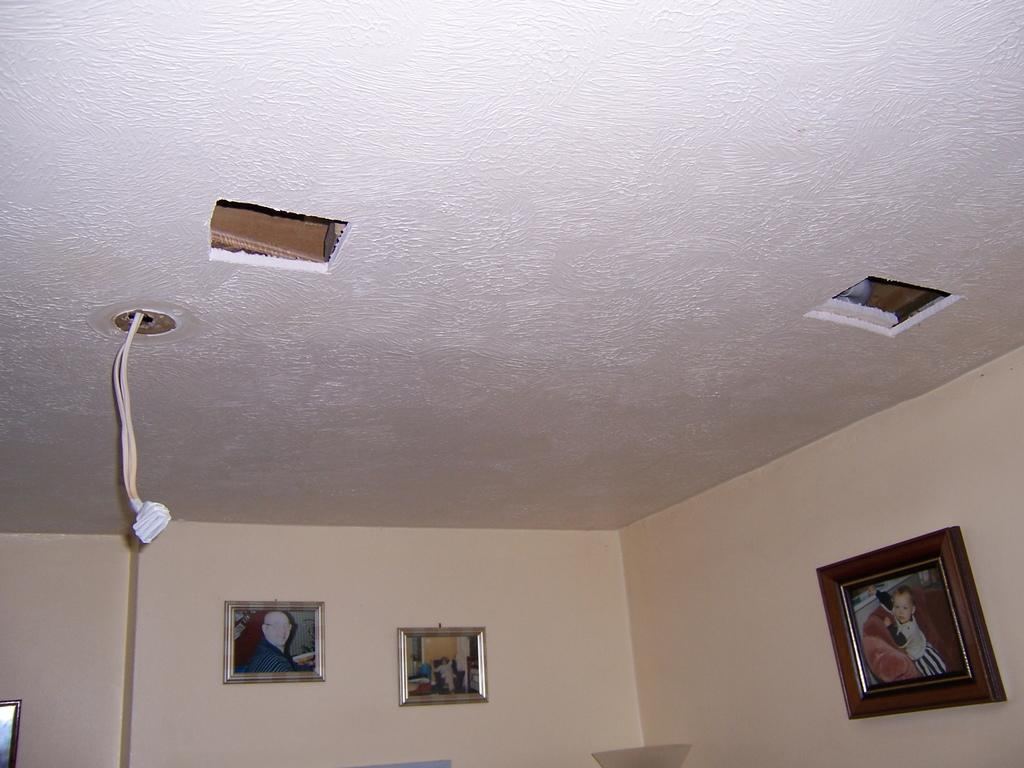Where was the image taken? The image was taken inside a room. What can be seen on the wall in the background of the image? There are two photo frames on a wall in the background of the image. What is visible at the top of the image? There is a ceiling visible at the top of the image. What type of scent can be detected in the room from the image? There is no information about the scent in the room provided in the image, so it cannot be determined. 